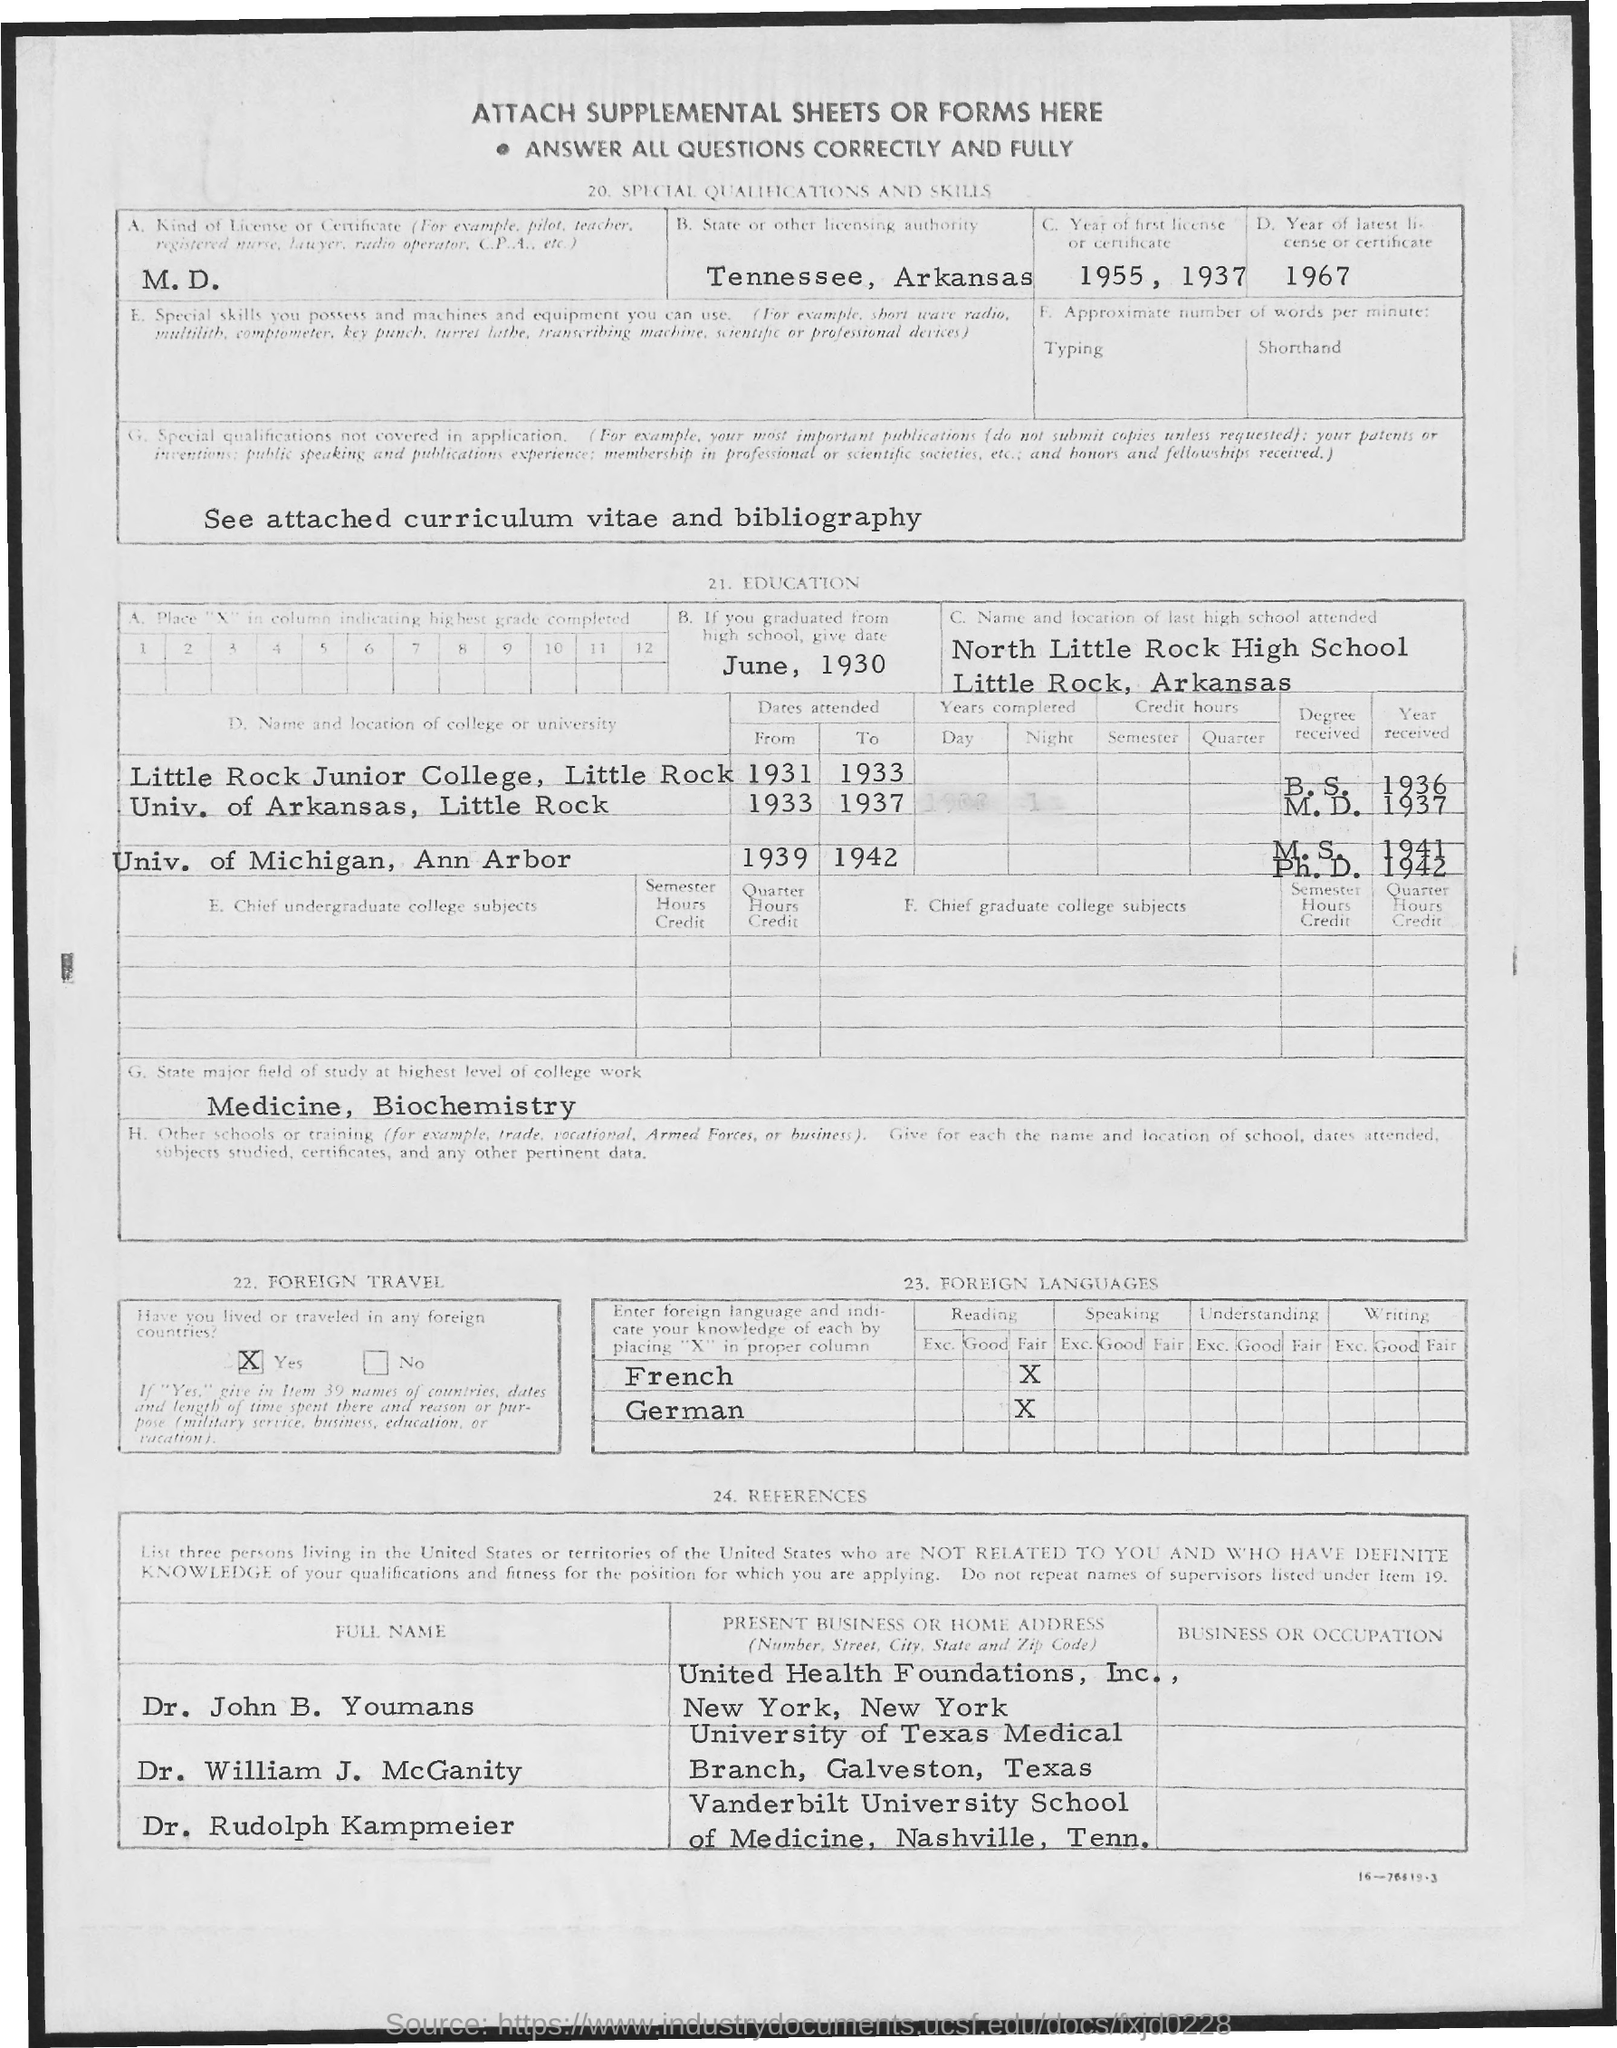What is the first title in the document?
Offer a very short reply. Attach Supplemental sheets or forms here. What is the name of the last high school attended?
Your response must be concise. NORTH LITTLE ROCK HIGH SCHOOL. What is the location of the last high school attended?
Keep it short and to the point. Little Rock, Arkansas. What is the name of the state or other licensing authority?
Ensure brevity in your answer.  TENNESSEE, ARKANSAS. What is the name of the major field of study at the highest level of college work?
Offer a terse response. Medicine, Biochemistry. What is the type of license?
Provide a short and direct response. M.D. 